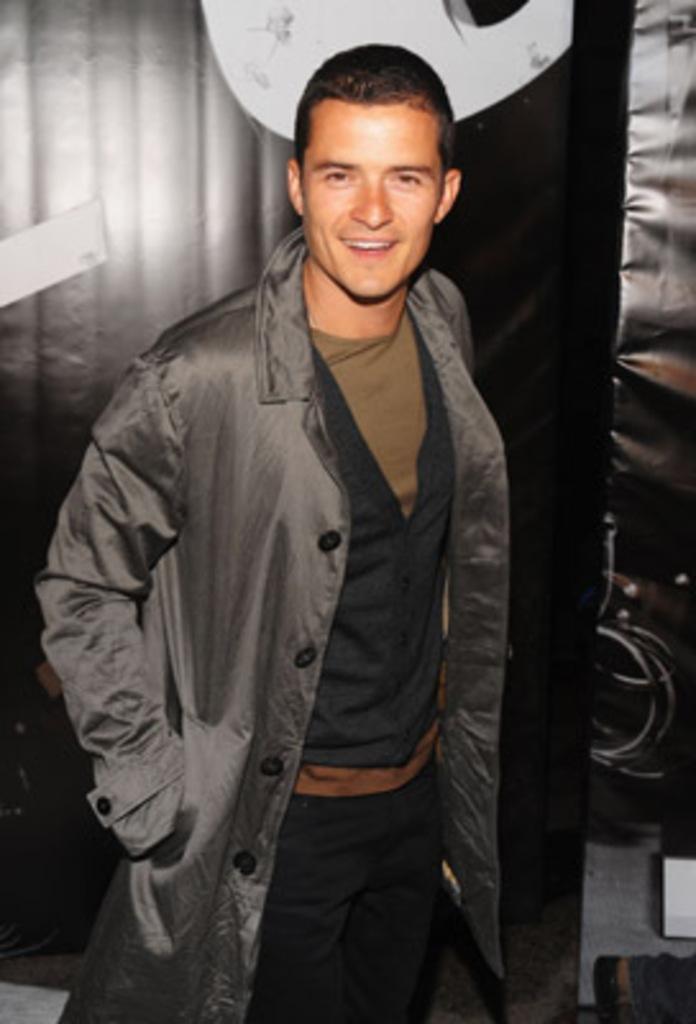How would you summarize this image in a sentence or two? In this picture we can observe a person standing, wearing a grey color coat. He is smiling. In the background there is a curtain which is in grey and black color. 